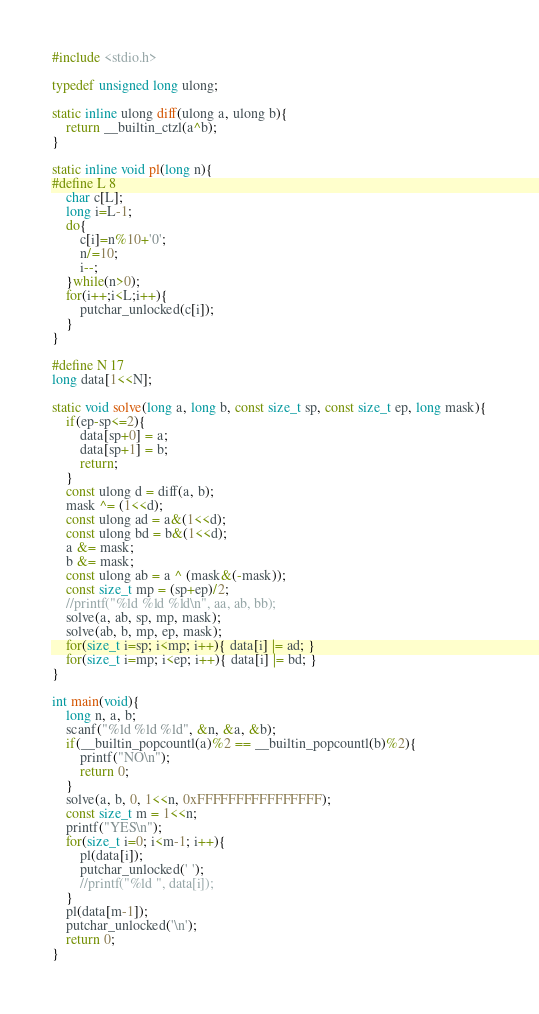<code> <loc_0><loc_0><loc_500><loc_500><_C_>#include <stdio.h>

typedef unsigned long ulong;

static inline ulong diff(ulong a, ulong b){
    return __builtin_ctzl(a^b);
}

static inline void pl(long n){
#define L 8
    char c[L];
    long i=L-1;
    do{
        c[i]=n%10+'0';
        n/=10;
        i--;
    }while(n>0);
    for(i++;i<L;i++){
        putchar_unlocked(c[i]);
    }
}

#define N 17
long data[1<<N];

static void solve(long a, long b, const size_t sp, const size_t ep, long mask){
    if(ep-sp<=2){
        data[sp+0] = a;
        data[sp+1] = b;
        return;
    }
    const ulong d = diff(a, b);
    mask ^= (1<<d);
    const ulong ad = a&(1<<d);
    const ulong bd = b&(1<<d);
    a &= mask;
    b &= mask;
    const ulong ab = a ^ (mask&(-mask));
    const size_t mp = (sp+ep)/2;
    //printf("%ld %ld %ld\n", aa, ab, bb);
    solve(a, ab, sp, mp, mask);
    solve(ab, b, mp, ep, mask);
    for(size_t i=sp; i<mp; i++){ data[i] |= ad; }
    for(size_t i=mp; i<ep; i++){ data[i] |= bd; }
}

int main(void){
    long n, a, b;
    scanf("%ld %ld %ld", &n, &a, &b);
    if(__builtin_popcountl(a)%2 == __builtin_popcountl(b)%2){
        printf("NO\n");
        return 0;
    }
    solve(a, b, 0, 1<<n, 0xFFFFFFFFFFFFFFFF);
    const size_t m = 1<<n;
    printf("YES\n");
    for(size_t i=0; i<m-1; i++){
        pl(data[i]);
        putchar_unlocked(' ');
        //printf("%ld ", data[i]);
    }
    pl(data[m-1]);
    putchar_unlocked('\n');
    return 0;
}</code> 